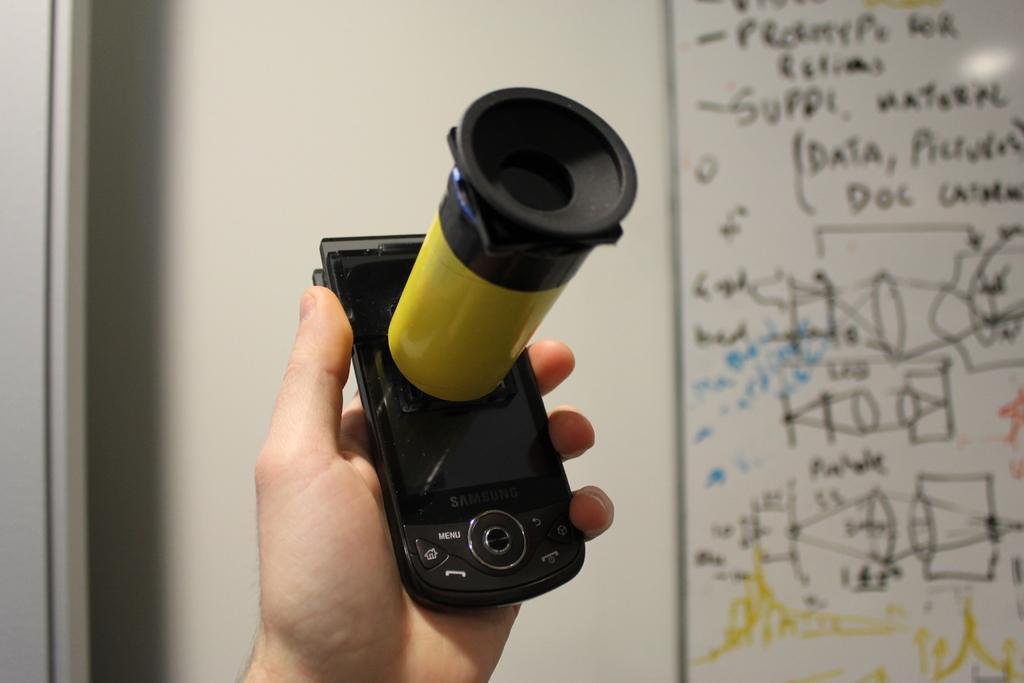Who or what is present in the image? There is a person in the image. What is the person holding in the image? The person is holding a mobile in the image. What can be seen in the background of the image? There is a board in the background of the image. What type of truck can be seen in the image? A: There is no truck present in the image; it only features a person holding a mobile and a board in the background. 